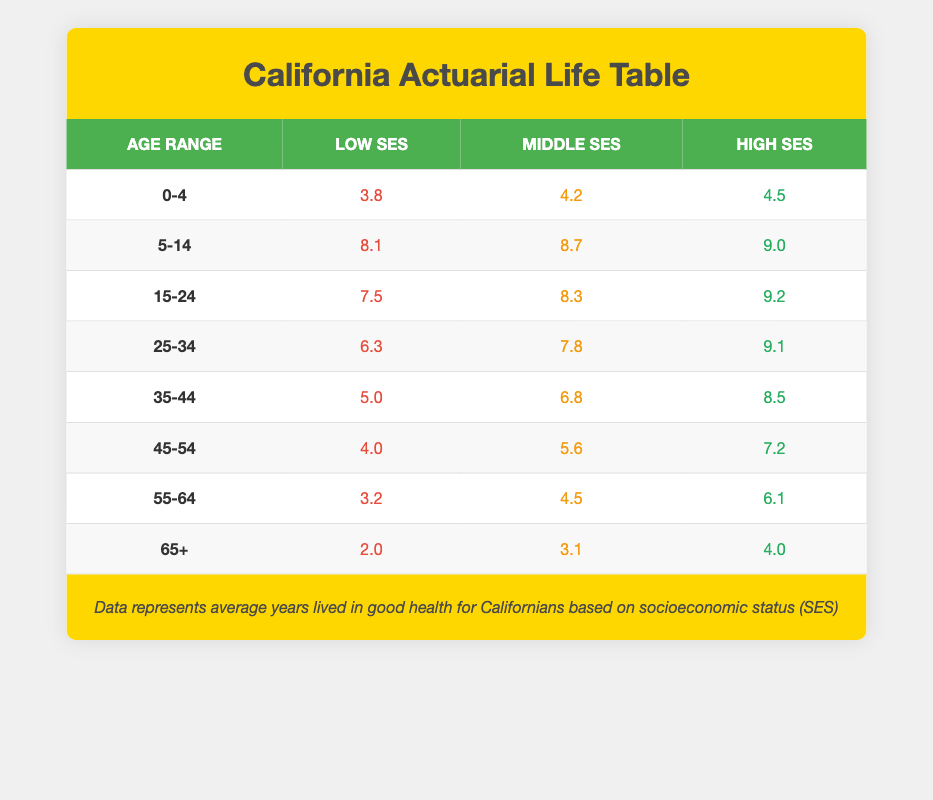What is the average number of years lived in good health for low socioeconomic status individuals aged 0-4 in California? According to the table, the average years lived in good health for low socioeconomic status individuals aged 0-4 is directly listed as 3.8.
Answer: 3.8 How many more years in good health do high socioeconomic status individuals aged 25-34 have compared to those with low socioeconomic status? For high socioeconomic status individuals aged 25-34, the average years in good health is 9.1, while for low socioeconomic status, it is 6.3. The difference is 9.1 - 6.3 = 2.8 years.
Answer: 2.8 Is the average number of years lived in good health higher for middle socioeconomic status individuals aged 55-64 compared to those aged 45-54? For middle socioeconomic status individuals aged 55-64, the average years in good health is 4.5, and for those aged 45-54, it is 5.6. Since 4.5 is less than 5.6, the statement is false.
Answer: No What is the average number of years lived in good health for high socioeconomic status individuals across all age groups? To find the average for high socioeconomic status, sum the values: 4.5 (0-4) + 9.0 (5-14) + 9.2 (15-24) + 9.1 (25-34) + 8.5 (35-44) + 7.2 (45-54) + 6.1 (55-64) + 4.0 (65+) = 57.4. Then divide by 8 (the number of age groups): 57.4 / 8 = 7.175.
Answer: 7.175 Are there any age groups where the average years in good health for low socioeconomic status individuals is greater than 5 years? Analyzing the ages, the only group with an average above 5 years is the age group 5-14 at 8.1 years. The other groups (0-4, 15-24, 25-34, 35-44, 45-54, 55-64, and 65+) have averages below 5. Thus, this statement is false.
Answer: No Which socioeconomic status category shows the highest average years lived in good health for individuals aged 15-24? For individuals aged 15-24, the averages are: Low SES is 7.5, Middle SES is 8.3, and High SES is 9.2. High socioeconomic status has the highest average with 9.2 years.
Answer: High SES What is the difference in average years lived in good health between low socioeconomic status individuals aged 65+ and those aged 0-4? The average for low socioeconomic status individuals aged 65+ is 2.0 years, and for those aged 0-4, it is 3.8 years. The difference is 3.8 - 2.0 = 1.8 years.
Answer: 1.8 For middle socioeconomic status individuals, what is the average years lived in good health for those aged 35-44 and 45-54 combined? The averages are 6.8 years for ages 35-44 and 5.6 years for ages 45-54. Combined, this is 6.8 + 5.6 = 12.4. Dividing by 2 (the two groups) gives an average of 12.4 / 2 = 6.2 years.
Answer: 6.2 